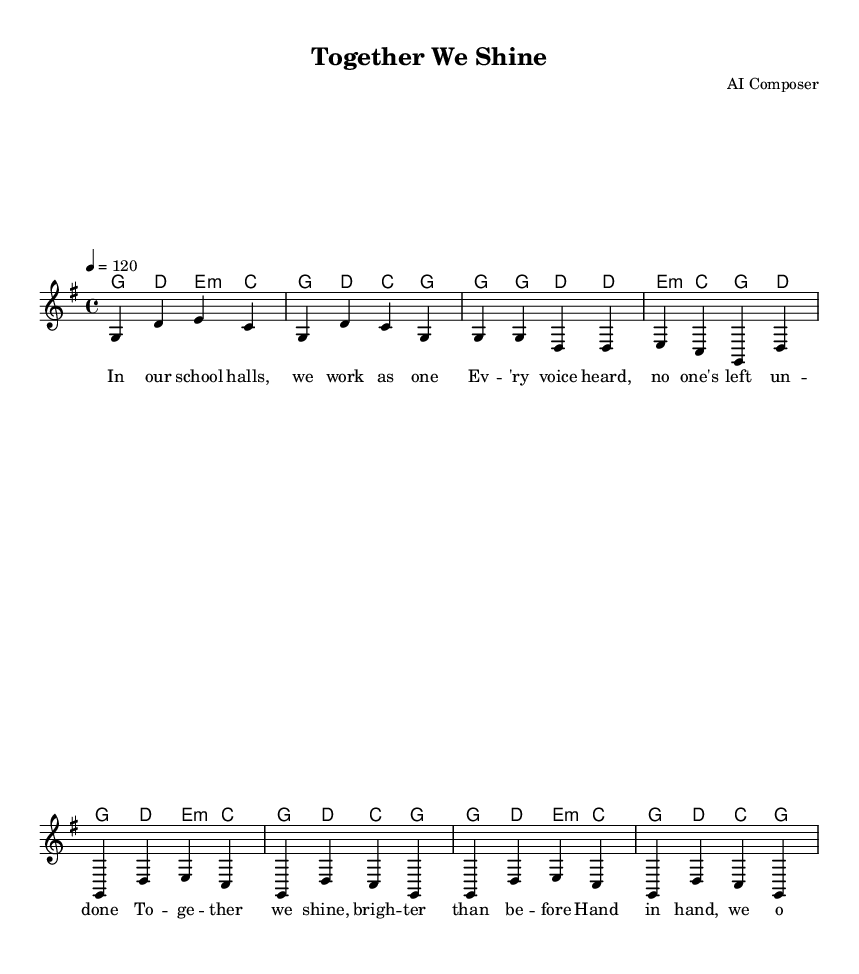What is the key signature of this music? The key signature is G major, which has one sharp (F#). This is indicated at the beginning of the sheet music.
Answer: G major What is the time signature of this music? The time signature is 4/4, showing that there are four beats in a measure, with the quarter note getting one beat. This is typically noted at the beginning of the piece.
Answer: 4/4 What is the tempo marking for this piece? The tempo marking is "4 = 120," indicating that the quarter note should be played at a speed of 120 beats per minute. This is specified at the beginning of the score under the global settings.
Answer: 120 How many measures are in the chorus section? The chorus consists of 4 measures as indicated in the score where the music breaks for the chorus part. The measures are several distinct segments of music that are grouped together.
Answer: 4 What is the title of the piece? The title is listed at the top of the sheet music as "Together We Shine." This is clearly indicated in the header section.
Answer: Together We Shine In which section of the song do the lyrics begin with "In our school halls, we work as one"? These lyrics begin in the verse section, which is the part of the song that tells a story or conveys a message, occurring after the introductory music.
Answer: Verse What do the lyrics suggest about teamwork? The lyrics highlight the theme of collaboration, suggesting that working together in school leads to brighter outcomes and opens doors for everyone. This reflects an emphasis on community involvement and unity in achievement.
Answer: Collaboration 